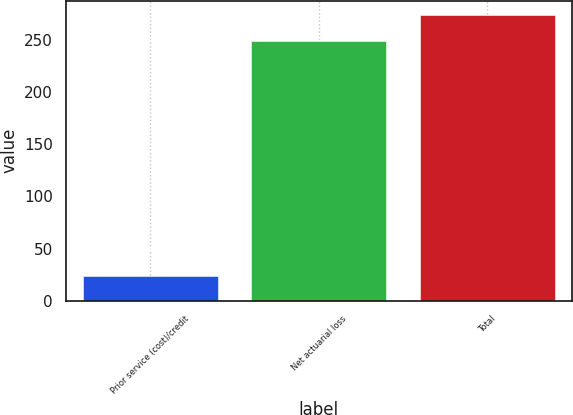<chart> <loc_0><loc_0><loc_500><loc_500><bar_chart><fcel>Prior service (cost)/credit<fcel>Net actuarial loss<fcel>Total<nl><fcel>24<fcel>249<fcel>273.9<nl></chart> 